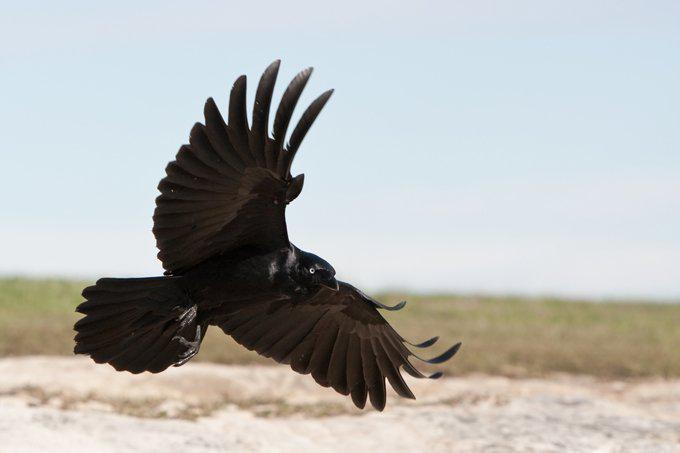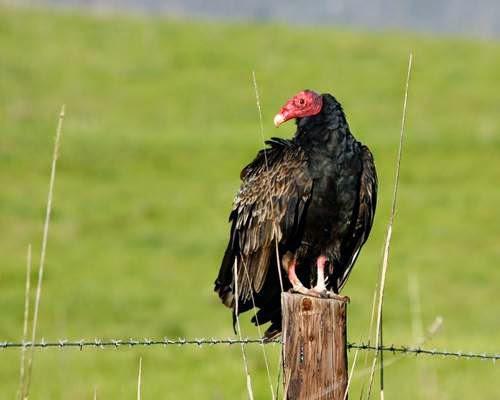The first image is the image on the left, the second image is the image on the right. Evaluate the accuracy of this statement regarding the images: "A vulture is sitting on a branch of dead wood with segments that extend up beside its body.". Is it true? Answer yes or no. No. 